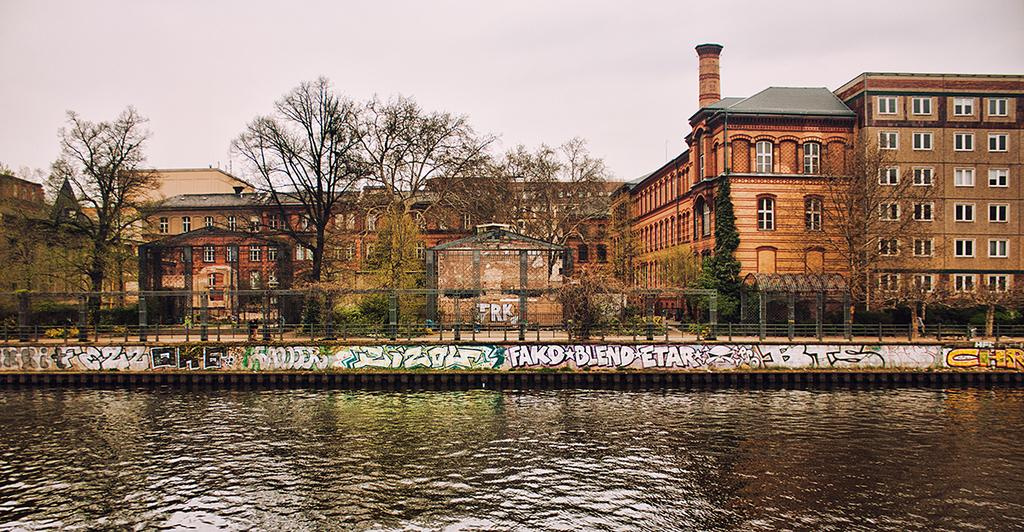What is the color of the building in the image? The building in the image is brown. What color are the windows on the building? The windows on the building are white. What type of vegetation can be seen in the image? There are dry trees in the image. What is located in front of the building? There is a lake with water in front of the building. What is visible at the top of the image? The sky is visible at the top of the image. How many men are playing basketball in the image? There are no men or basketball present in the image. What type of vegetable is growing near the dry trees in the image? There are no vegetables present in the image; only dry trees can be seen. 